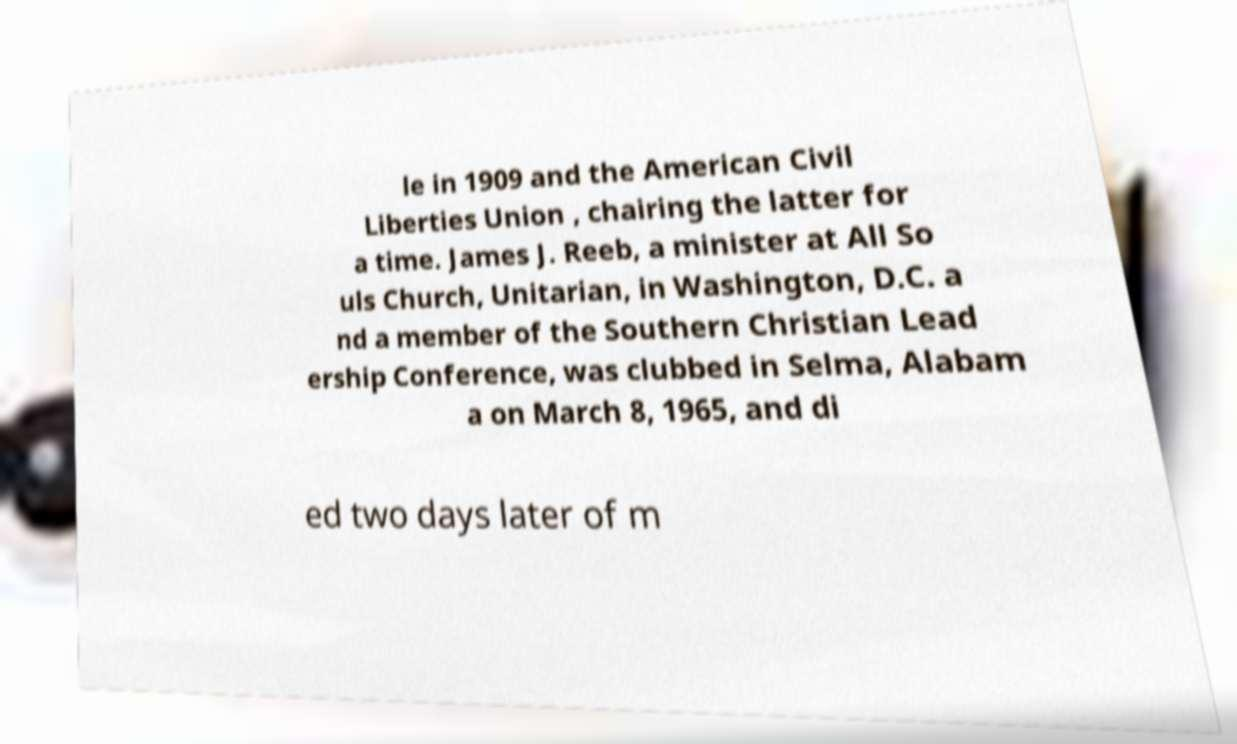Can you accurately transcribe the text from the provided image for me? le in 1909 and the American Civil Liberties Union , chairing the latter for a time. James J. Reeb, a minister at All So uls Church, Unitarian, in Washington, D.C. a nd a member of the Southern Christian Lead ership Conference, was clubbed in Selma, Alabam a on March 8, 1965, and di ed two days later of m 